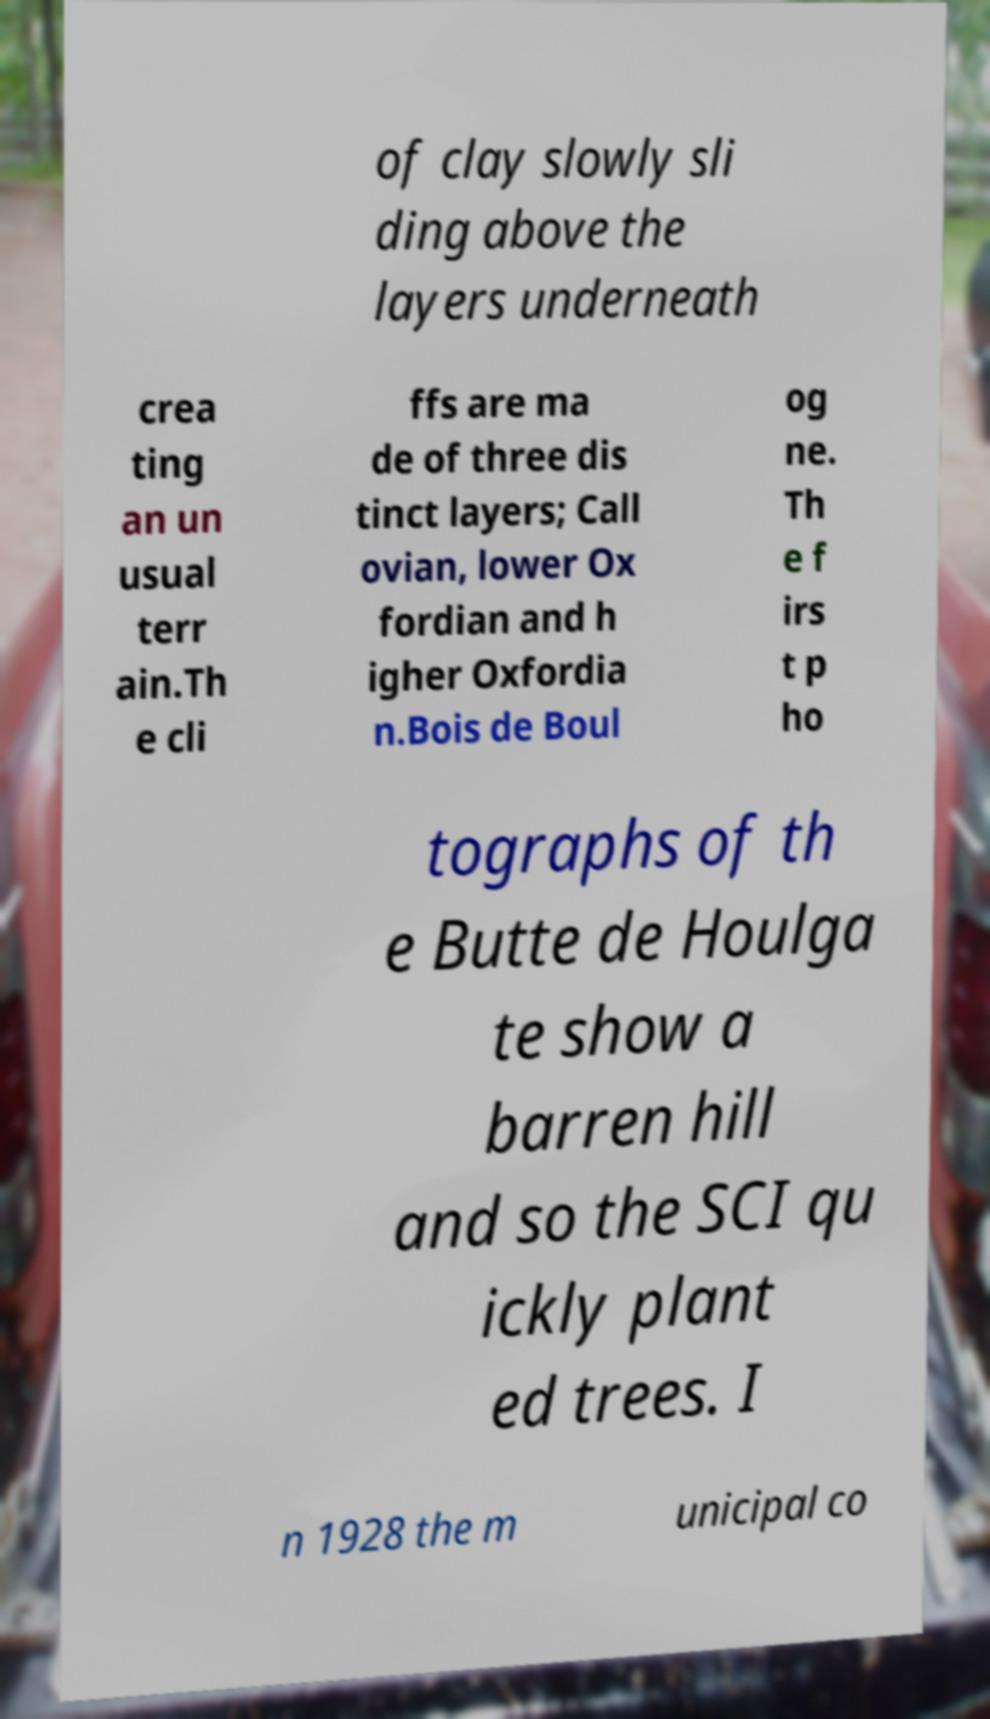Can you accurately transcribe the text from the provided image for me? of clay slowly sli ding above the layers underneath crea ting an un usual terr ain.Th e cli ffs are ma de of three dis tinct layers; Call ovian, lower Ox fordian and h igher Oxfordia n.Bois de Boul og ne. Th e f irs t p ho tographs of th e Butte de Houlga te show a barren hill and so the SCI qu ickly plant ed trees. I n 1928 the m unicipal co 